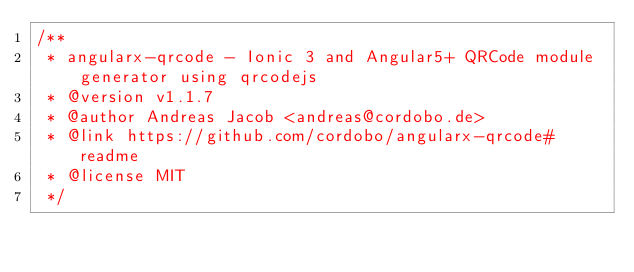<code> <loc_0><loc_0><loc_500><loc_500><_JavaScript_>/**
 * angularx-qrcode - Ionic 3 and Angular5+ QRCode module generator using qrcodejs
 * @version v1.1.7
 * @author Andreas Jacob <andreas@cordobo.de>
 * @link https://github.com/cordobo/angularx-qrcode#readme
 * @license MIT
 */</code> 